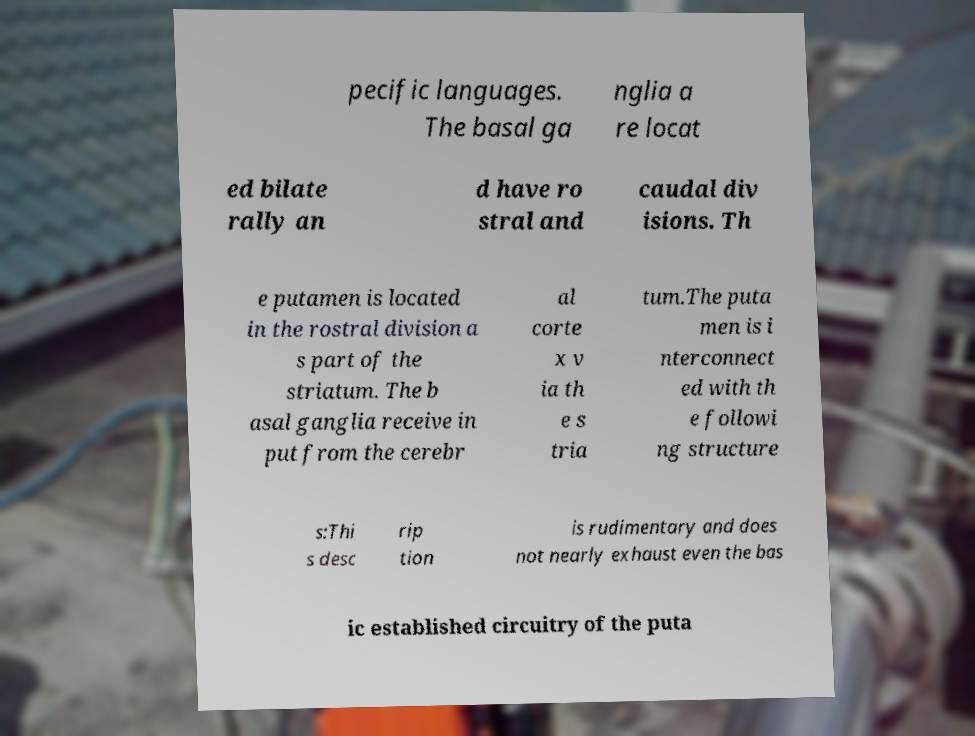Can you read and provide the text displayed in the image?This photo seems to have some interesting text. Can you extract and type it out for me? pecific languages. The basal ga nglia a re locat ed bilate rally an d have ro stral and caudal div isions. Th e putamen is located in the rostral division a s part of the striatum. The b asal ganglia receive in put from the cerebr al corte x v ia th e s tria tum.The puta men is i nterconnect ed with th e followi ng structure s:Thi s desc rip tion is rudimentary and does not nearly exhaust even the bas ic established circuitry of the puta 